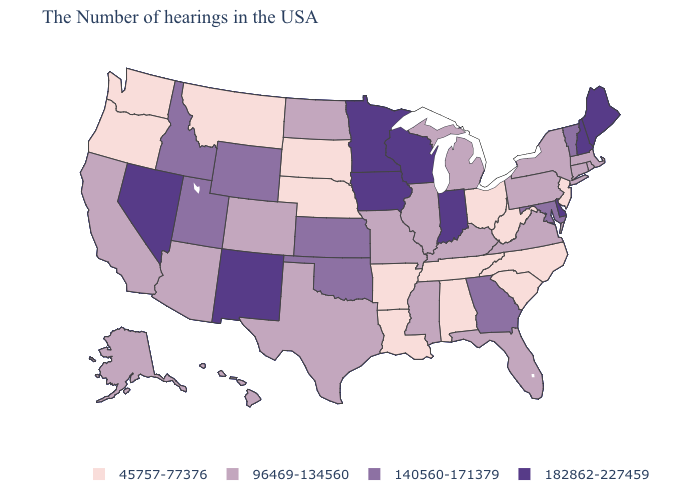Which states have the lowest value in the USA?
Write a very short answer. New Jersey, North Carolina, South Carolina, West Virginia, Ohio, Alabama, Tennessee, Louisiana, Arkansas, Nebraska, South Dakota, Montana, Washington, Oregon. What is the highest value in the USA?
Write a very short answer. 182862-227459. Name the states that have a value in the range 182862-227459?
Keep it brief. Maine, New Hampshire, Delaware, Indiana, Wisconsin, Minnesota, Iowa, New Mexico, Nevada. How many symbols are there in the legend?
Be succinct. 4. What is the value of Arkansas?
Give a very brief answer. 45757-77376. Name the states that have a value in the range 140560-171379?
Write a very short answer. Vermont, Maryland, Georgia, Kansas, Oklahoma, Wyoming, Utah, Idaho. What is the highest value in states that border Colorado?
Be succinct. 182862-227459. Name the states that have a value in the range 45757-77376?
Write a very short answer. New Jersey, North Carolina, South Carolina, West Virginia, Ohio, Alabama, Tennessee, Louisiana, Arkansas, Nebraska, South Dakota, Montana, Washington, Oregon. What is the value of Wyoming?
Quick response, please. 140560-171379. Name the states that have a value in the range 45757-77376?
Write a very short answer. New Jersey, North Carolina, South Carolina, West Virginia, Ohio, Alabama, Tennessee, Louisiana, Arkansas, Nebraska, South Dakota, Montana, Washington, Oregon. What is the value of Iowa?
Concise answer only. 182862-227459. What is the value of Hawaii?
Short answer required. 96469-134560. What is the value of Missouri?
Answer briefly. 96469-134560. Is the legend a continuous bar?
Concise answer only. No. Name the states that have a value in the range 182862-227459?
Give a very brief answer. Maine, New Hampshire, Delaware, Indiana, Wisconsin, Minnesota, Iowa, New Mexico, Nevada. 